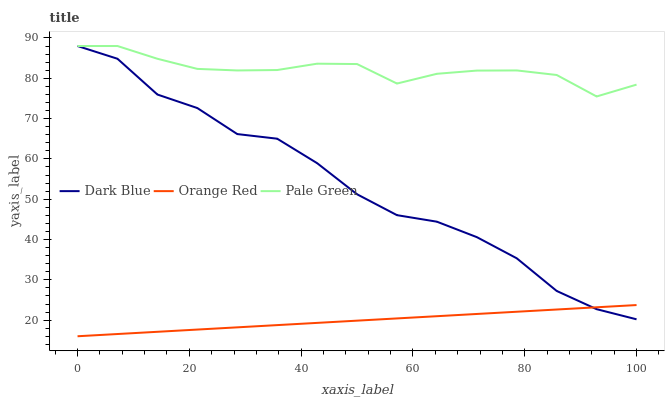Does Orange Red have the minimum area under the curve?
Answer yes or no. Yes. Does Pale Green have the maximum area under the curve?
Answer yes or no. Yes. Does Pale Green have the minimum area under the curve?
Answer yes or no. No. Does Orange Red have the maximum area under the curve?
Answer yes or no. No. Is Orange Red the smoothest?
Answer yes or no. Yes. Is Dark Blue the roughest?
Answer yes or no. Yes. Is Pale Green the smoothest?
Answer yes or no. No. Is Pale Green the roughest?
Answer yes or no. No. Does Orange Red have the lowest value?
Answer yes or no. Yes. Does Pale Green have the lowest value?
Answer yes or no. No. Does Pale Green have the highest value?
Answer yes or no. Yes. Does Orange Red have the highest value?
Answer yes or no. No. Is Orange Red less than Pale Green?
Answer yes or no. Yes. Is Pale Green greater than Orange Red?
Answer yes or no. Yes. Does Pale Green intersect Dark Blue?
Answer yes or no. Yes. Is Pale Green less than Dark Blue?
Answer yes or no. No. Is Pale Green greater than Dark Blue?
Answer yes or no. No. Does Orange Red intersect Pale Green?
Answer yes or no. No. 